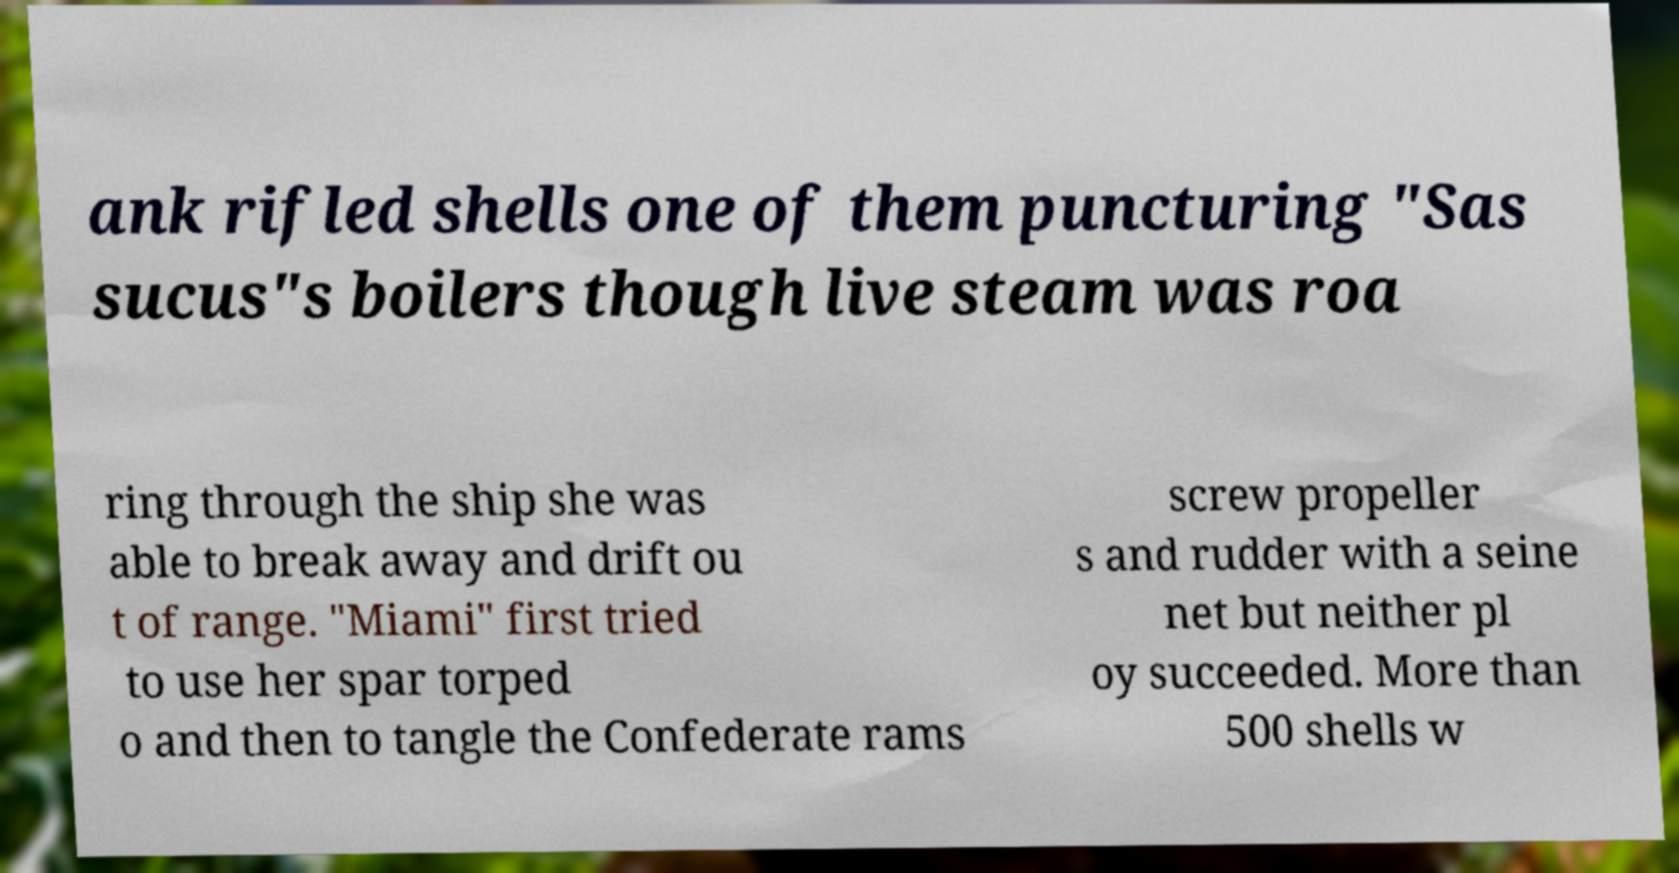What messages or text are displayed in this image? I need them in a readable, typed format. ank rifled shells one of them puncturing "Sas sucus"s boilers though live steam was roa ring through the ship she was able to break away and drift ou t of range. "Miami" first tried to use her spar torped o and then to tangle the Confederate rams screw propeller s and rudder with a seine net but neither pl oy succeeded. More than 500 shells w 